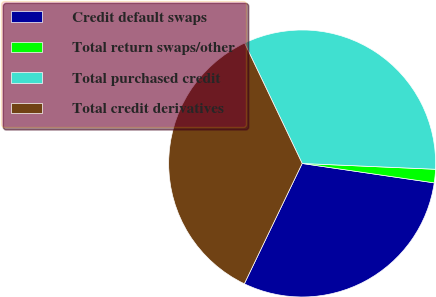Convert chart to OTSL. <chart><loc_0><loc_0><loc_500><loc_500><pie_chart><fcel>Credit default swaps<fcel>Total return swaps/other<fcel>Total purchased credit<fcel>Total credit derivatives<nl><fcel>29.81%<fcel>1.63%<fcel>32.79%<fcel>35.77%<nl></chart> 